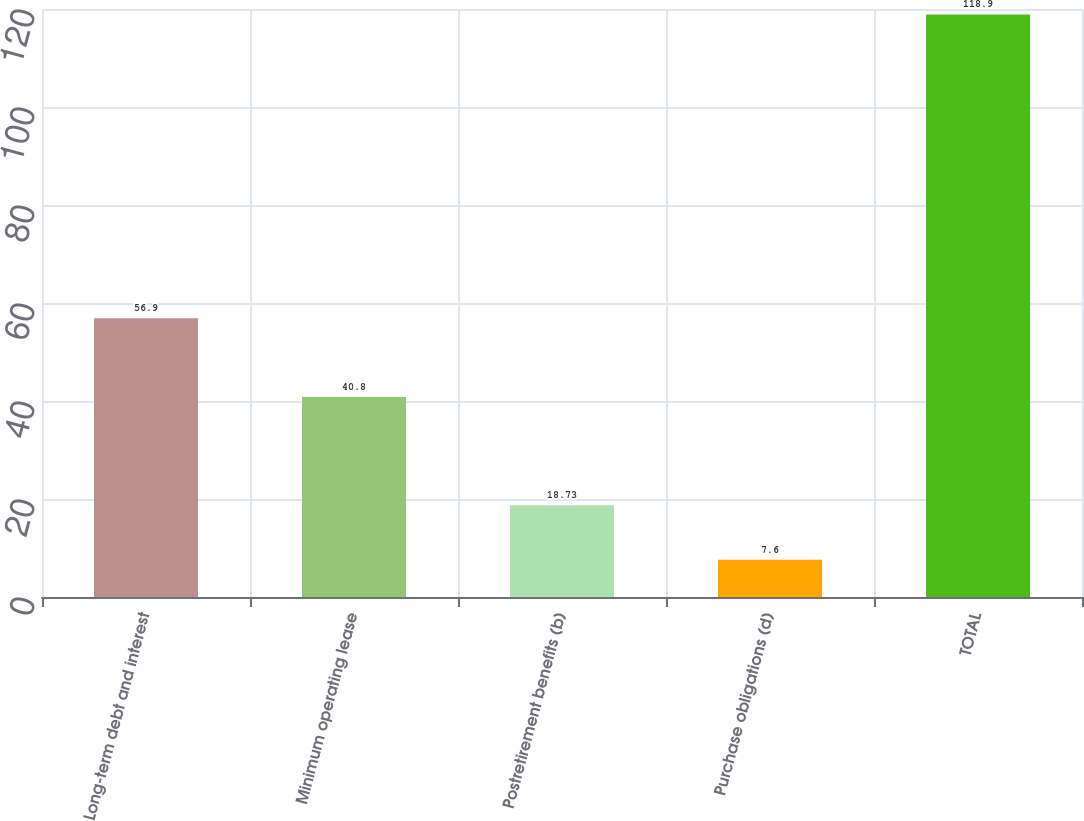Convert chart. <chart><loc_0><loc_0><loc_500><loc_500><bar_chart><fcel>Long-term debt and interest<fcel>Minimum operating lease<fcel>Postretirement benefits (b)<fcel>Purchase obligations (d)<fcel>TOTAL<nl><fcel>56.9<fcel>40.8<fcel>18.73<fcel>7.6<fcel>118.9<nl></chart> 